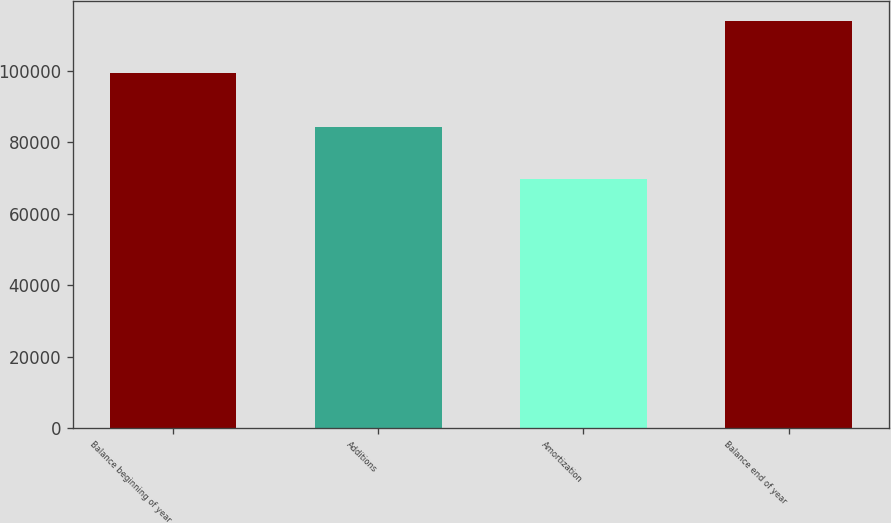Convert chart. <chart><loc_0><loc_0><loc_500><loc_500><bar_chart><fcel>Balance beginning of year<fcel>Additions<fcel>Amortization<fcel>Balance end of year<nl><fcel>99265<fcel>84274<fcel>69718<fcel>113821<nl></chart> 